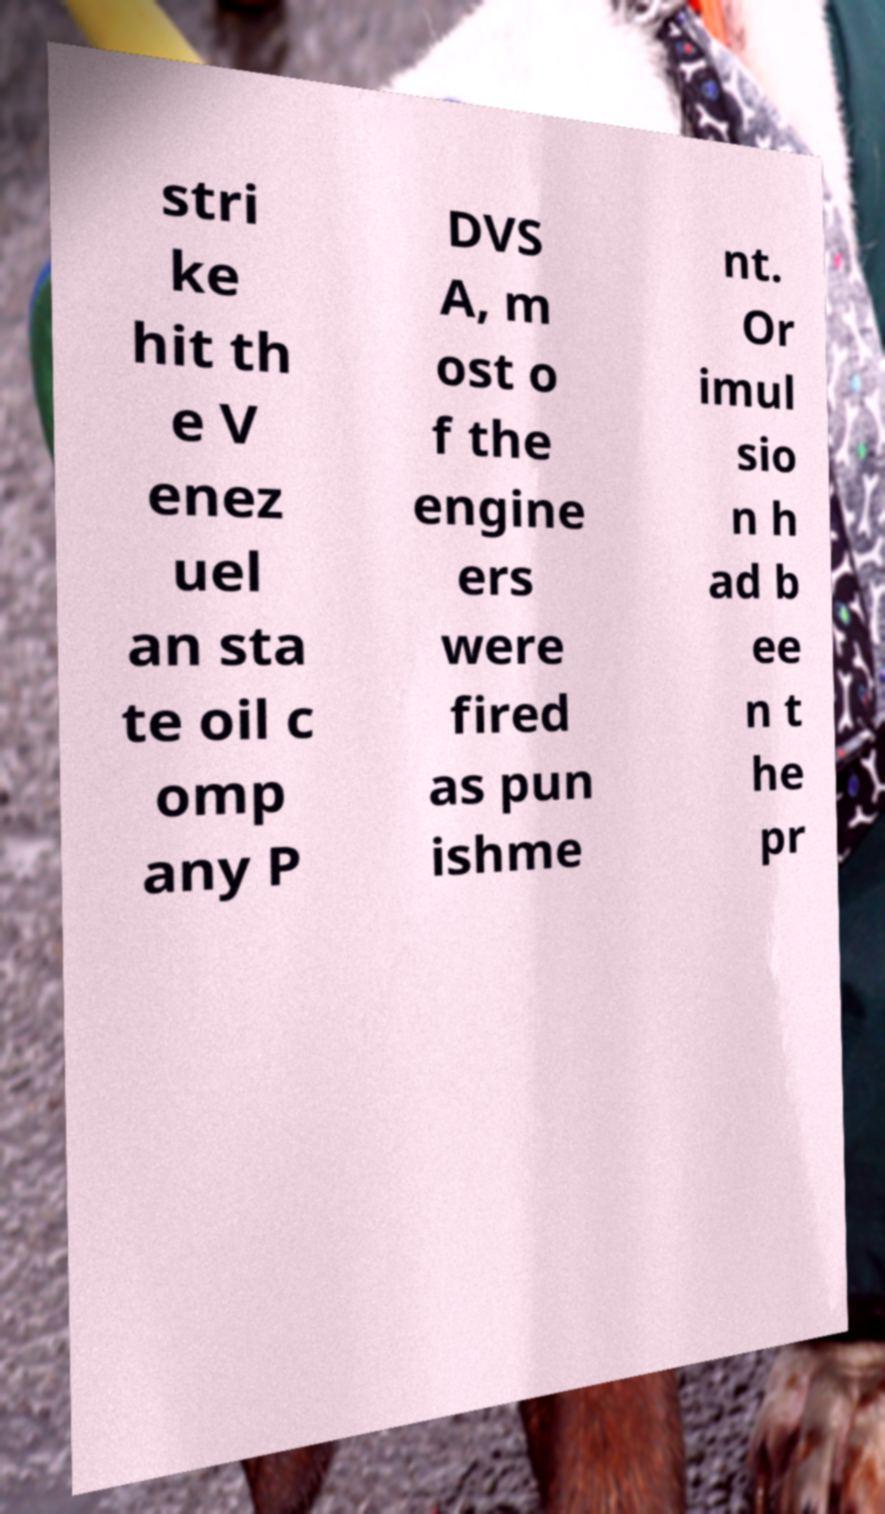Can you accurately transcribe the text from the provided image for me? stri ke hit th e V enez uel an sta te oil c omp any P DVS A, m ost o f the engine ers were fired as pun ishme nt. Or imul sio n h ad b ee n t he pr 